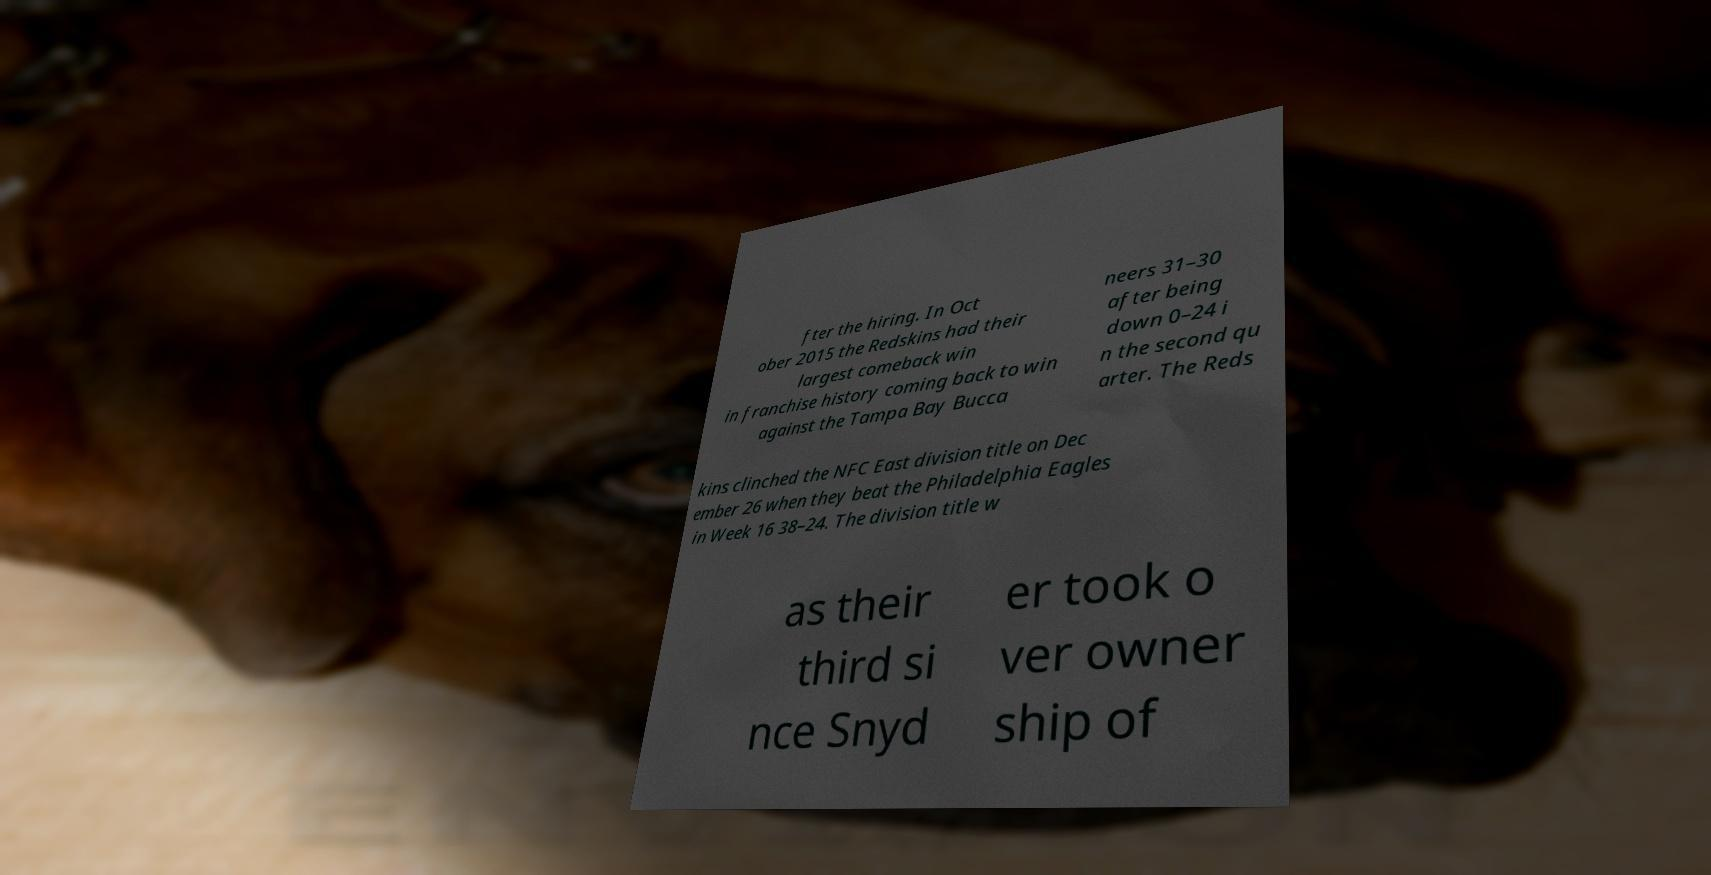Please read and relay the text visible in this image. What does it say? fter the hiring. In Oct ober 2015 the Redskins had their largest comeback win in franchise history coming back to win against the Tampa Bay Bucca neers 31–30 after being down 0–24 i n the second qu arter. The Reds kins clinched the NFC East division title on Dec ember 26 when they beat the Philadelphia Eagles in Week 16 38–24. The division title w as their third si nce Snyd er took o ver owner ship of 